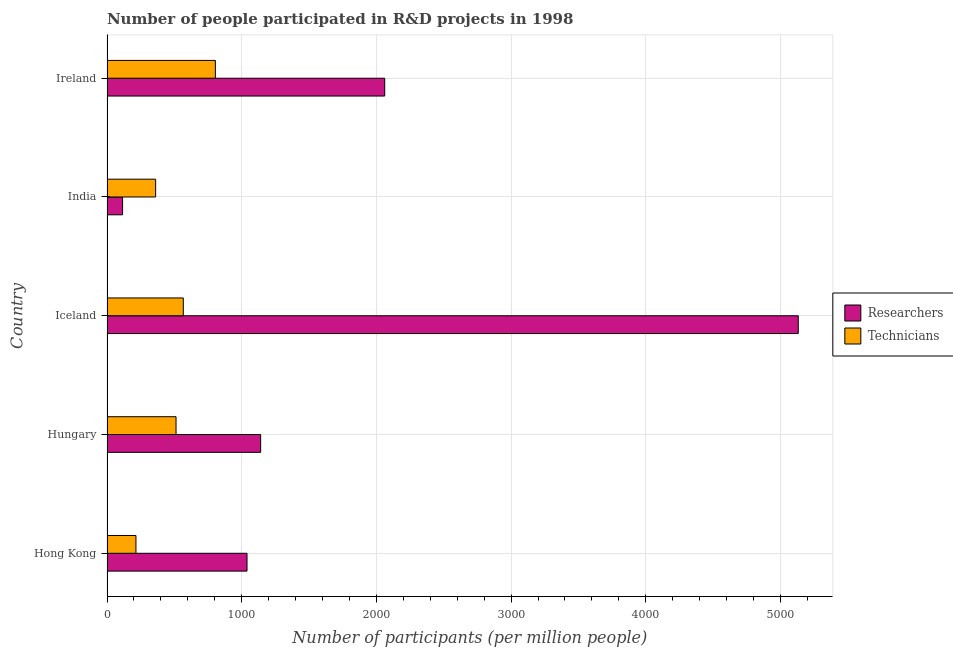How many different coloured bars are there?
Provide a short and direct response. 2. How many groups of bars are there?
Offer a terse response. 5. Are the number of bars per tick equal to the number of legend labels?
Give a very brief answer. Yes. Are the number of bars on each tick of the Y-axis equal?
Keep it short and to the point. Yes. How many bars are there on the 2nd tick from the top?
Your answer should be compact. 2. What is the label of the 2nd group of bars from the top?
Offer a very short reply. India. In how many cases, is the number of bars for a given country not equal to the number of legend labels?
Offer a terse response. 0. What is the number of researchers in Iceland?
Offer a very short reply. 5132.28. Across all countries, what is the maximum number of technicians?
Offer a terse response. 804.64. Across all countries, what is the minimum number of researchers?
Your answer should be compact. 115.63. In which country was the number of technicians maximum?
Keep it short and to the point. Ireland. In which country was the number of technicians minimum?
Provide a succinct answer. Hong Kong. What is the total number of researchers in the graph?
Offer a very short reply. 9490.15. What is the difference between the number of technicians in Hungary and that in India?
Offer a very short reply. 151.39. What is the difference between the number of technicians in Hong Kong and the number of researchers in Iceland?
Offer a terse response. -4917.32. What is the average number of technicians per country?
Keep it short and to the point. 491.97. What is the difference between the number of researchers and number of technicians in Ireland?
Provide a short and direct response. 1257.23. What is the ratio of the number of researchers in Iceland to that in India?
Offer a very short reply. 44.38. Is the number of technicians in Iceland less than that in India?
Offer a terse response. No. What is the difference between the highest and the second highest number of technicians?
Keep it short and to the point. 238.11. What is the difference between the highest and the lowest number of researchers?
Your response must be concise. 5016.65. In how many countries, is the number of technicians greater than the average number of technicians taken over all countries?
Offer a very short reply. 3. What does the 1st bar from the top in Hungary represents?
Your answer should be compact. Technicians. What does the 2nd bar from the bottom in Ireland represents?
Offer a very short reply. Technicians. Are all the bars in the graph horizontal?
Your response must be concise. Yes. Are the values on the major ticks of X-axis written in scientific E-notation?
Provide a succinct answer. No. Does the graph contain grids?
Provide a succinct answer. Yes. Where does the legend appear in the graph?
Your response must be concise. Center right. How many legend labels are there?
Keep it short and to the point. 2. What is the title of the graph?
Make the answer very short. Number of people participated in R&D projects in 1998. What is the label or title of the X-axis?
Your answer should be very brief. Number of participants (per million people). What is the Number of participants (per million people) in Researchers in Hong Kong?
Keep it short and to the point. 1039.54. What is the Number of participants (per million people) of Technicians in Hong Kong?
Offer a terse response. 214.96. What is the Number of participants (per million people) of Researchers in Hungary?
Your answer should be very brief. 1140.82. What is the Number of participants (per million people) of Technicians in Hungary?
Offer a terse response. 512.54. What is the Number of participants (per million people) of Researchers in Iceland?
Make the answer very short. 5132.28. What is the Number of participants (per million people) in Technicians in Iceland?
Your answer should be very brief. 566.53. What is the Number of participants (per million people) in Researchers in India?
Your response must be concise. 115.63. What is the Number of participants (per million people) in Technicians in India?
Ensure brevity in your answer.  361.15. What is the Number of participants (per million people) of Researchers in Ireland?
Give a very brief answer. 2061.87. What is the Number of participants (per million people) of Technicians in Ireland?
Give a very brief answer. 804.64. Across all countries, what is the maximum Number of participants (per million people) in Researchers?
Your answer should be very brief. 5132.28. Across all countries, what is the maximum Number of participants (per million people) of Technicians?
Your answer should be compact. 804.64. Across all countries, what is the minimum Number of participants (per million people) in Researchers?
Offer a very short reply. 115.63. Across all countries, what is the minimum Number of participants (per million people) of Technicians?
Ensure brevity in your answer.  214.96. What is the total Number of participants (per million people) of Researchers in the graph?
Ensure brevity in your answer.  9490.15. What is the total Number of participants (per million people) of Technicians in the graph?
Offer a terse response. 2459.83. What is the difference between the Number of participants (per million people) in Researchers in Hong Kong and that in Hungary?
Keep it short and to the point. -101.29. What is the difference between the Number of participants (per million people) of Technicians in Hong Kong and that in Hungary?
Your response must be concise. -297.58. What is the difference between the Number of participants (per million people) in Researchers in Hong Kong and that in Iceland?
Offer a terse response. -4092.75. What is the difference between the Number of participants (per million people) of Technicians in Hong Kong and that in Iceland?
Provide a short and direct response. -351.58. What is the difference between the Number of participants (per million people) in Researchers in Hong Kong and that in India?
Your response must be concise. 923.9. What is the difference between the Number of participants (per million people) in Technicians in Hong Kong and that in India?
Provide a succinct answer. -146.19. What is the difference between the Number of participants (per million people) of Researchers in Hong Kong and that in Ireland?
Provide a short and direct response. -1022.34. What is the difference between the Number of participants (per million people) of Technicians in Hong Kong and that in Ireland?
Make the answer very short. -589.68. What is the difference between the Number of participants (per million people) in Researchers in Hungary and that in Iceland?
Provide a succinct answer. -3991.46. What is the difference between the Number of participants (per million people) of Technicians in Hungary and that in Iceland?
Provide a succinct answer. -53.99. What is the difference between the Number of participants (per million people) of Researchers in Hungary and that in India?
Your answer should be very brief. 1025.19. What is the difference between the Number of participants (per million people) of Technicians in Hungary and that in India?
Keep it short and to the point. 151.39. What is the difference between the Number of participants (per million people) in Researchers in Hungary and that in Ireland?
Keep it short and to the point. -921.05. What is the difference between the Number of participants (per million people) of Technicians in Hungary and that in Ireland?
Make the answer very short. -292.1. What is the difference between the Number of participants (per million people) in Researchers in Iceland and that in India?
Provide a short and direct response. 5016.65. What is the difference between the Number of participants (per million people) in Technicians in Iceland and that in India?
Make the answer very short. 205.38. What is the difference between the Number of participants (per million people) in Researchers in Iceland and that in Ireland?
Your response must be concise. 3070.41. What is the difference between the Number of participants (per million people) of Technicians in Iceland and that in Ireland?
Offer a terse response. -238.11. What is the difference between the Number of participants (per million people) of Researchers in India and that in Ireland?
Offer a very short reply. -1946.24. What is the difference between the Number of participants (per million people) in Technicians in India and that in Ireland?
Keep it short and to the point. -443.49. What is the difference between the Number of participants (per million people) in Researchers in Hong Kong and the Number of participants (per million people) in Technicians in Hungary?
Ensure brevity in your answer.  527. What is the difference between the Number of participants (per million people) of Researchers in Hong Kong and the Number of participants (per million people) of Technicians in Iceland?
Offer a very short reply. 473. What is the difference between the Number of participants (per million people) of Researchers in Hong Kong and the Number of participants (per million people) of Technicians in India?
Your answer should be compact. 678.38. What is the difference between the Number of participants (per million people) in Researchers in Hong Kong and the Number of participants (per million people) in Technicians in Ireland?
Keep it short and to the point. 234.89. What is the difference between the Number of participants (per million people) of Researchers in Hungary and the Number of participants (per million people) of Technicians in Iceland?
Keep it short and to the point. 574.29. What is the difference between the Number of participants (per million people) in Researchers in Hungary and the Number of participants (per million people) in Technicians in India?
Offer a very short reply. 779.67. What is the difference between the Number of participants (per million people) in Researchers in Hungary and the Number of participants (per million people) in Technicians in Ireland?
Your answer should be very brief. 336.18. What is the difference between the Number of participants (per million people) in Researchers in Iceland and the Number of participants (per million people) in Technicians in India?
Make the answer very short. 4771.13. What is the difference between the Number of participants (per million people) in Researchers in Iceland and the Number of participants (per million people) in Technicians in Ireland?
Offer a terse response. 4327.64. What is the difference between the Number of participants (per million people) in Researchers in India and the Number of participants (per million people) in Technicians in Ireland?
Ensure brevity in your answer.  -689.01. What is the average Number of participants (per million people) in Researchers per country?
Provide a succinct answer. 1898.03. What is the average Number of participants (per million people) of Technicians per country?
Give a very brief answer. 491.97. What is the difference between the Number of participants (per million people) in Researchers and Number of participants (per million people) in Technicians in Hong Kong?
Your response must be concise. 824.58. What is the difference between the Number of participants (per million people) in Researchers and Number of participants (per million people) in Technicians in Hungary?
Give a very brief answer. 628.28. What is the difference between the Number of participants (per million people) in Researchers and Number of participants (per million people) in Technicians in Iceland?
Your answer should be very brief. 4565.75. What is the difference between the Number of participants (per million people) of Researchers and Number of participants (per million people) of Technicians in India?
Keep it short and to the point. -245.52. What is the difference between the Number of participants (per million people) of Researchers and Number of participants (per million people) of Technicians in Ireland?
Your response must be concise. 1257.23. What is the ratio of the Number of participants (per million people) in Researchers in Hong Kong to that in Hungary?
Ensure brevity in your answer.  0.91. What is the ratio of the Number of participants (per million people) in Technicians in Hong Kong to that in Hungary?
Give a very brief answer. 0.42. What is the ratio of the Number of participants (per million people) in Researchers in Hong Kong to that in Iceland?
Offer a very short reply. 0.2. What is the ratio of the Number of participants (per million people) of Technicians in Hong Kong to that in Iceland?
Give a very brief answer. 0.38. What is the ratio of the Number of participants (per million people) of Researchers in Hong Kong to that in India?
Provide a succinct answer. 8.99. What is the ratio of the Number of participants (per million people) in Technicians in Hong Kong to that in India?
Offer a very short reply. 0.6. What is the ratio of the Number of participants (per million people) of Researchers in Hong Kong to that in Ireland?
Give a very brief answer. 0.5. What is the ratio of the Number of participants (per million people) of Technicians in Hong Kong to that in Ireland?
Ensure brevity in your answer.  0.27. What is the ratio of the Number of participants (per million people) of Researchers in Hungary to that in Iceland?
Your answer should be compact. 0.22. What is the ratio of the Number of participants (per million people) in Technicians in Hungary to that in Iceland?
Give a very brief answer. 0.9. What is the ratio of the Number of participants (per million people) in Researchers in Hungary to that in India?
Offer a very short reply. 9.87. What is the ratio of the Number of participants (per million people) of Technicians in Hungary to that in India?
Your answer should be compact. 1.42. What is the ratio of the Number of participants (per million people) in Researchers in Hungary to that in Ireland?
Provide a succinct answer. 0.55. What is the ratio of the Number of participants (per million people) of Technicians in Hungary to that in Ireland?
Provide a succinct answer. 0.64. What is the ratio of the Number of participants (per million people) in Researchers in Iceland to that in India?
Your answer should be compact. 44.38. What is the ratio of the Number of participants (per million people) of Technicians in Iceland to that in India?
Offer a very short reply. 1.57. What is the ratio of the Number of participants (per million people) of Researchers in Iceland to that in Ireland?
Give a very brief answer. 2.49. What is the ratio of the Number of participants (per million people) of Technicians in Iceland to that in Ireland?
Provide a short and direct response. 0.7. What is the ratio of the Number of participants (per million people) of Researchers in India to that in Ireland?
Your answer should be very brief. 0.06. What is the ratio of the Number of participants (per million people) in Technicians in India to that in Ireland?
Keep it short and to the point. 0.45. What is the difference between the highest and the second highest Number of participants (per million people) in Researchers?
Provide a succinct answer. 3070.41. What is the difference between the highest and the second highest Number of participants (per million people) in Technicians?
Make the answer very short. 238.11. What is the difference between the highest and the lowest Number of participants (per million people) of Researchers?
Make the answer very short. 5016.65. What is the difference between the highest and the lowest Number of participants (per million people) in Technicians?
Make the answer very short. 589.68. 